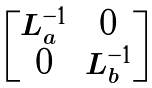Convert formula to latex. <formula><loc_0><loc_0><loc_500><loc_500>\begin{bmatrix} L _ { a } ^ { - 1 } & 0 \\ 0 & L _ { b } ^ { - 1 } \\ \end{bmatrix}</formula> 